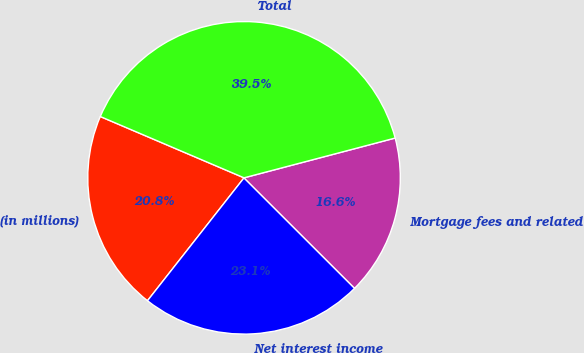Convert chart. <chart><loc_0><loc_0><loc_500><loc_500><pie_chart><fcel>(in millions)<fcel>Net interest income<fcel>Mortgage fees and related<fcel>Total<nl><fcel>20.82%<fcel>23.11%<fcel>16.59%<fcel>39.49%<nl></chart> 